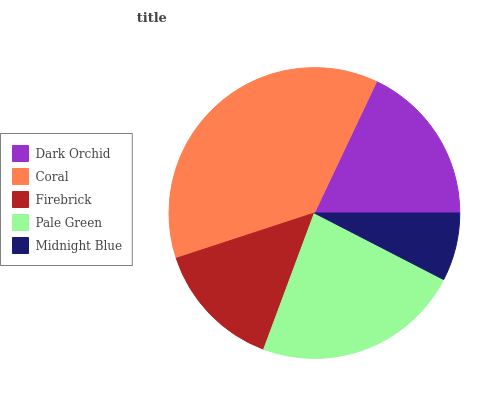Is Midnight Blue the minimum?
Answer yes or no. Yes. Is Coral the maximum?
Answer yes or no. Yes. Is Firebrick the minimum?
Answer yes or no. No. Is Firebrick the maximum?
Answer yes or no. No. Is Coral greater than Firebrick?
Answer yes or no. Yes. Is Firebrick less than Coral?
Answer yes or no. Yes. Is Firebrick greater than Coral?
Answer yes or no. No. Is Coral less than Firebrick?
Answer yes or no. No. Is Dark Orchid the high median?
Answer yes or no. Yes. Is Dark Orchid the low median?
Answer yes or no. Yes. Is Firebrick the high median?
Answer yes or no. No. Is Firebrick the low median?
Answer yes or no. No. 